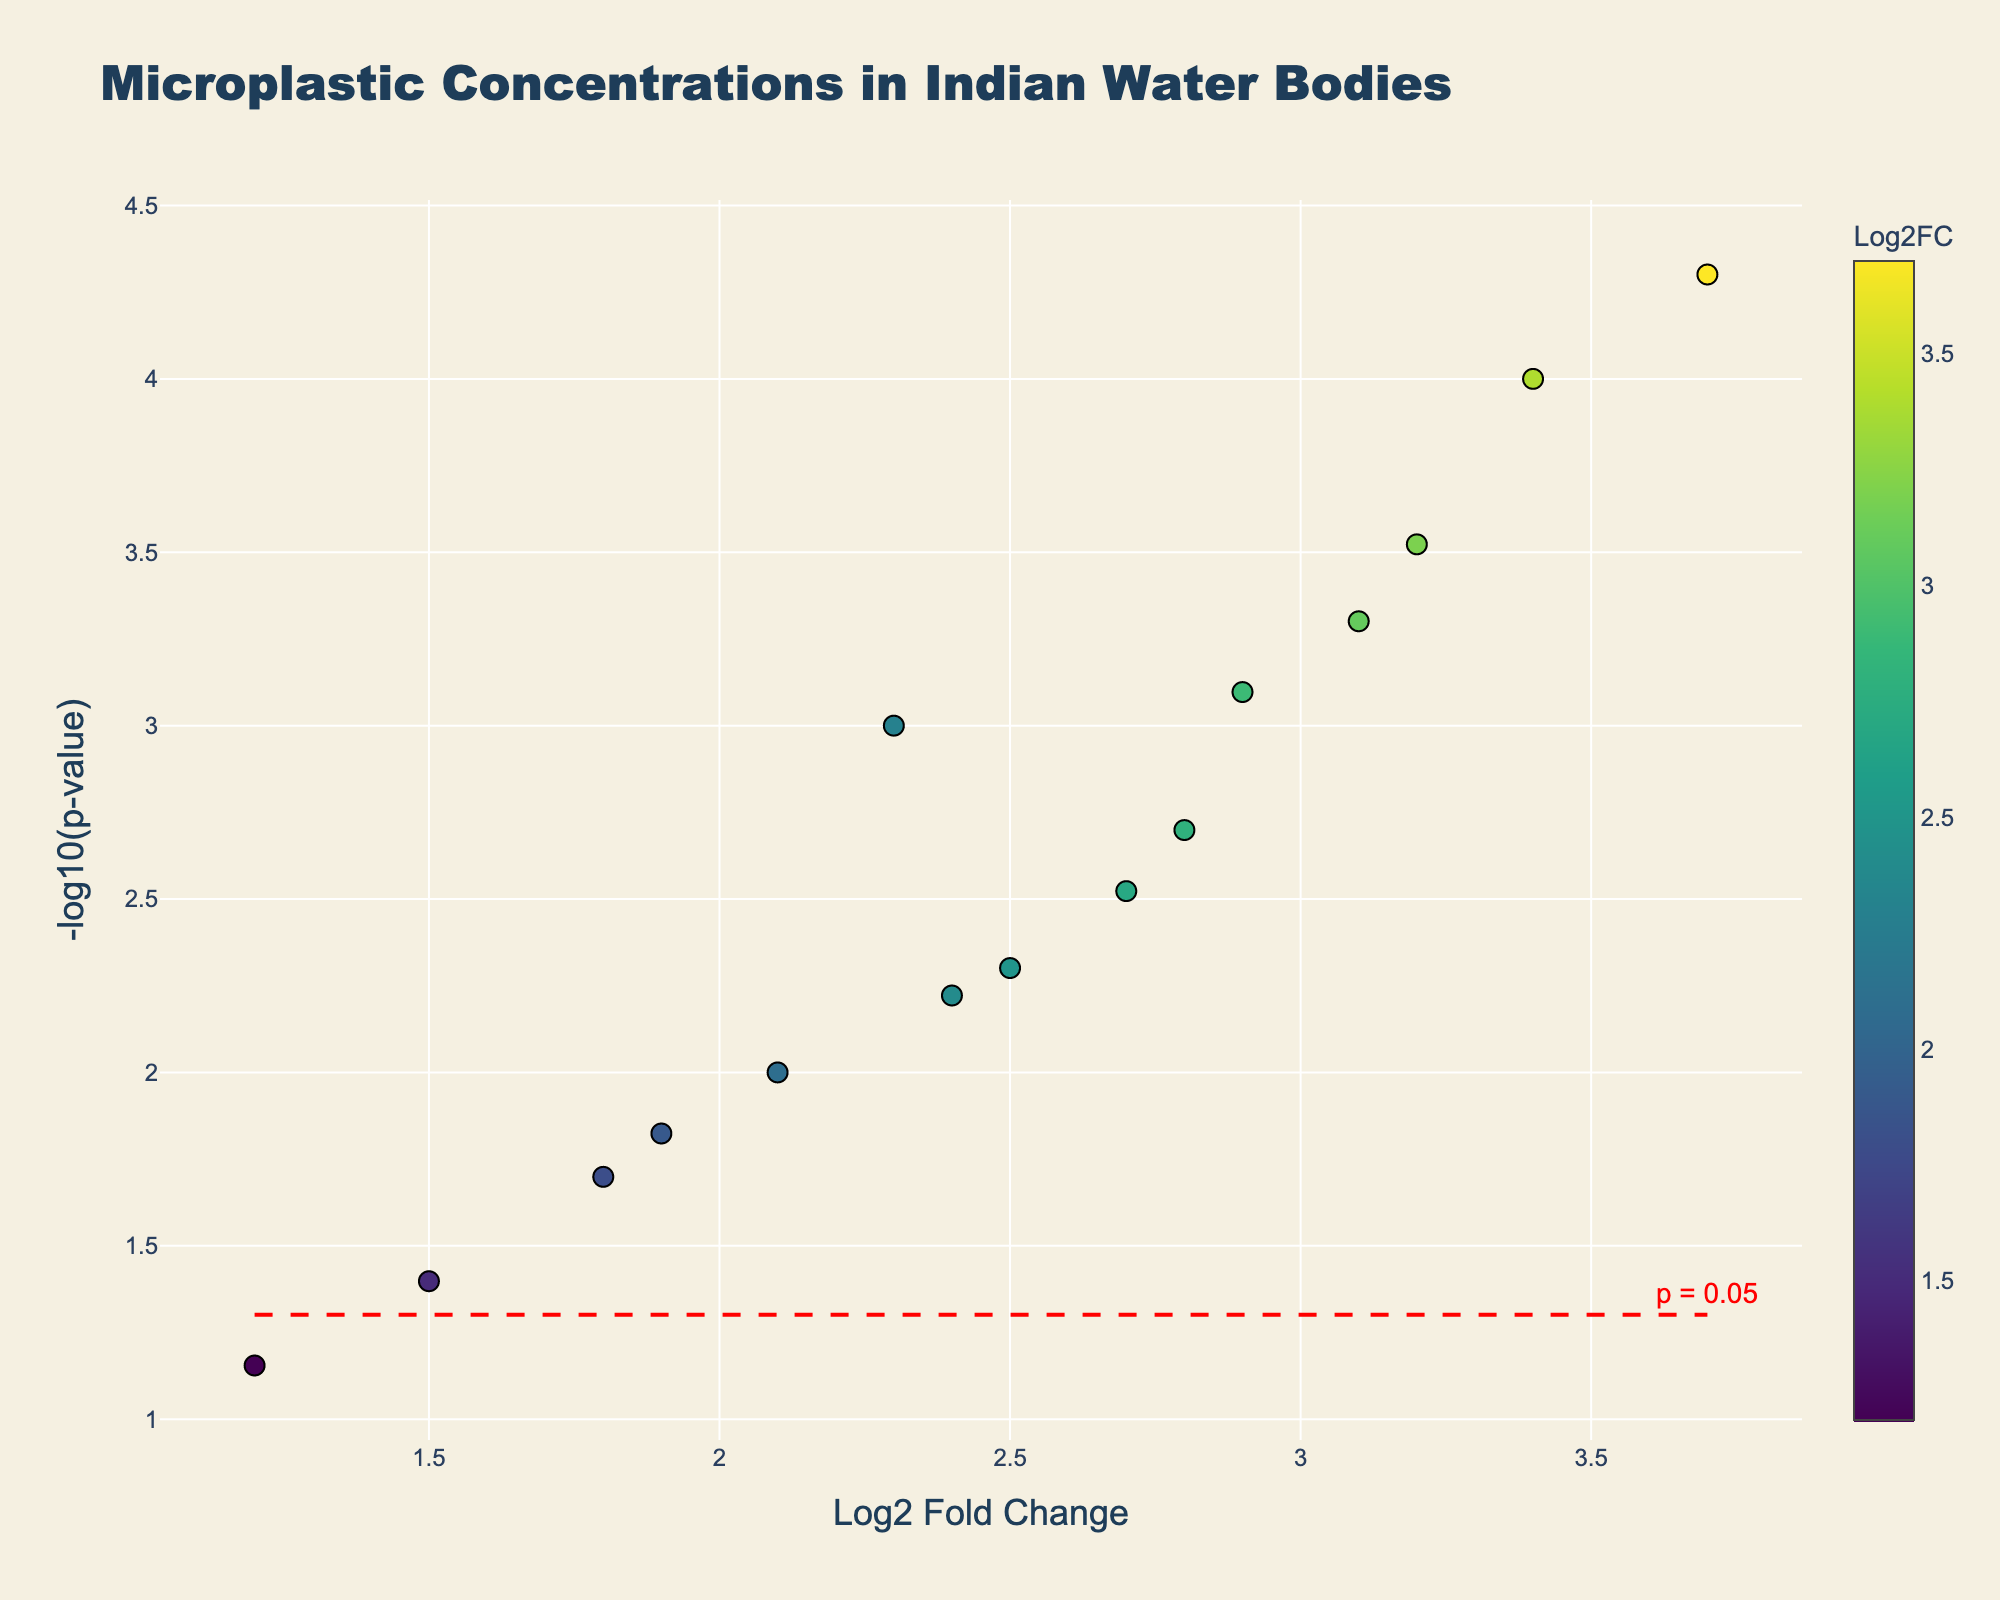What's the title of the plot? The title is displayed at the top of the plot and reads "Microplastic Concentrations in Indian Water Bodies".
Answer: Microplastic Concentrations in Indian Water Bodies Which water body has the highest Log2 Fold Change? By observing the x-axis values, Mumbai Harbor has the highest Log2 Fold Change at 3.7.
Answer: Mumbai Harbor How many sample sites have a p-value less than 0.05? The horizontal red dashed line represents the significance level at -log10(p-value) = 1.3. All points above this line signify p-values less than 0.05. By counting these points, there are 13.
Answer: 13 What is the Log2 Fold Change of the sample site from Dal Lake, Srinagar? The point corresponding to Dal Lake, Srinagar has an x-axis value of 3.4, which represents the Log2 Fold Change.
Answer: 3.4 What does the red horizontal dashed line represent? The red dashed line indicates the threshold for the significance level, specifically where the p-value equals 0.05 (-log10(0.05) ≈ 1.3).
Answer: p = 0.05 What is the y-axis title? The title of the y-axis is written vertically along the axis and reads "-log10(p-value)".
Answer: -log10(p-value) Compare the significance (p-value) of microplastic concentrations between the Yamuna River, Delhi, and Vembanad Lake, Kerala. Which is more significant? By comparing the y-axis values, Yamuna River, Delhi has a higher -log10(p-value) than Vembanad Lake, Kerala, indicating a more significant p-value.
Answer: Yamuna River, Delhi Which sample site has a higher Log2 Fold Change: Godavari River, Rajahmundry or Chennai Coast? By comparing the x-axis values of Godavari River, Rajahmundry (2.7) and Chennai Coast (2.8), Chennai Coast has a slightly higher Log2 Fold Change.
Answer: Chennai Coast What is the meaning of the color scale in the plot? The color scale on the right side of the plot corresponds to the Log2 Fold Changes of the sample sites, with varying colors indicating different levels of change.
Answer: Log2 Fold Change How does the p-value for Logatak Lake, Manipur compare to the significance threshold? The point for Loktak Lake, Manipur is above the red dashed line at -log10(p-value). This indicates its p-value is less than 0.05, making it significant.
Answer: Below threshold, significant 